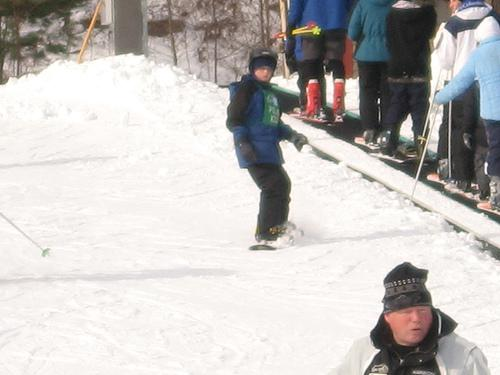Question: what is the boy doing?
Choices:
A. Skateboarding.
B. Riding a bike.
C. Swimming.
D. Snowboarding.
Answer with the letter. Answer: D Question: what is in the ground?
Choices:
A. Sand.
B. In the snow.
C. Dirt.
D. Grass.
Answer with the letter. Answer: B Question: what color jacket is the boy wearing?
Choices:
A. White.
B. Blue.
C. Green.
D. Red.
Answer with the letter. Answer: B Question: who is snowboarding down the mountain?
Choices:
A. A girl.
B. A woman.
C. A boy.
D. A man.
Answer with the letter. Answer: C 